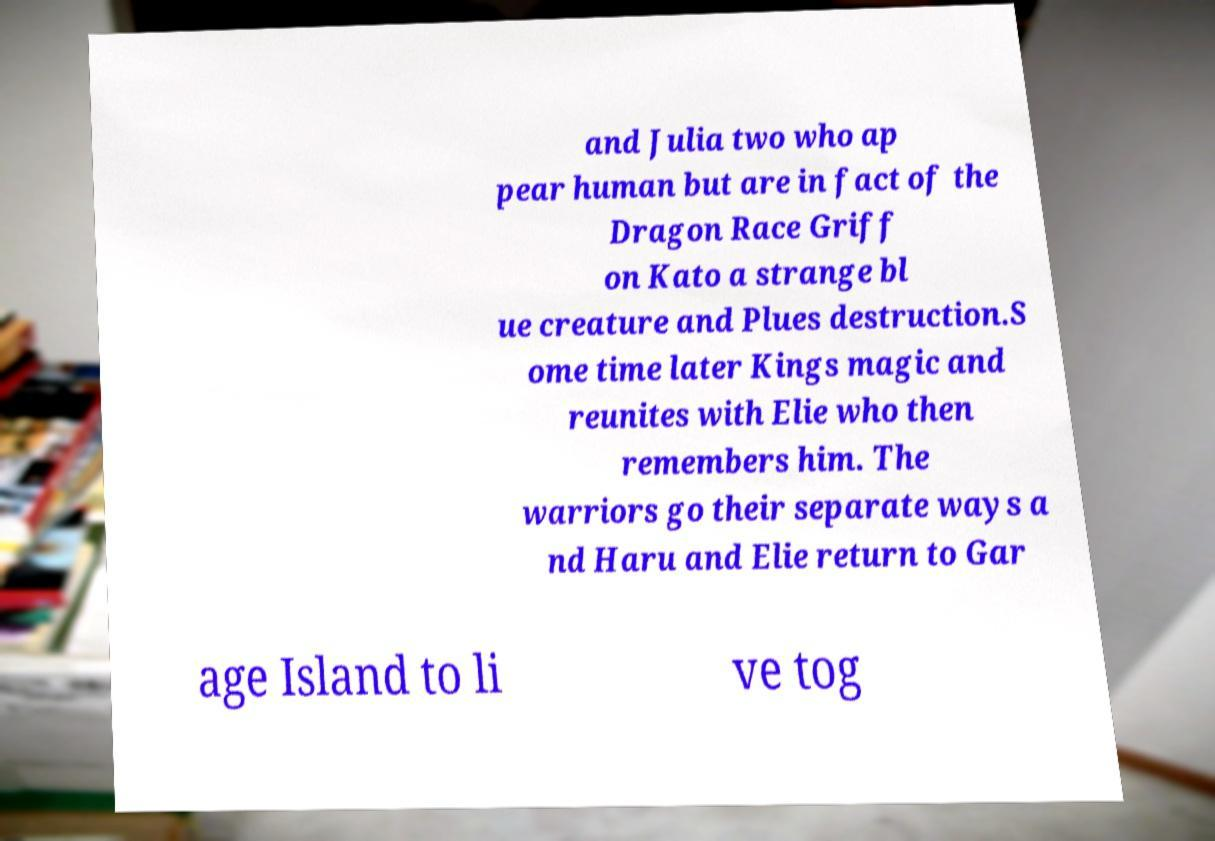What messages or text are displayed in this image? I need them in a readable, typed format. and Julia two who ap pear human but are in fact of the Dragon Race Griff on Kato a strange bl ue creature and Plues destruction.S ome time later Kings magic and reunites with Elie who then remembers him. The warriors go their separate ways a nd Haru and Elie return to Gar age Island to li ve tog 